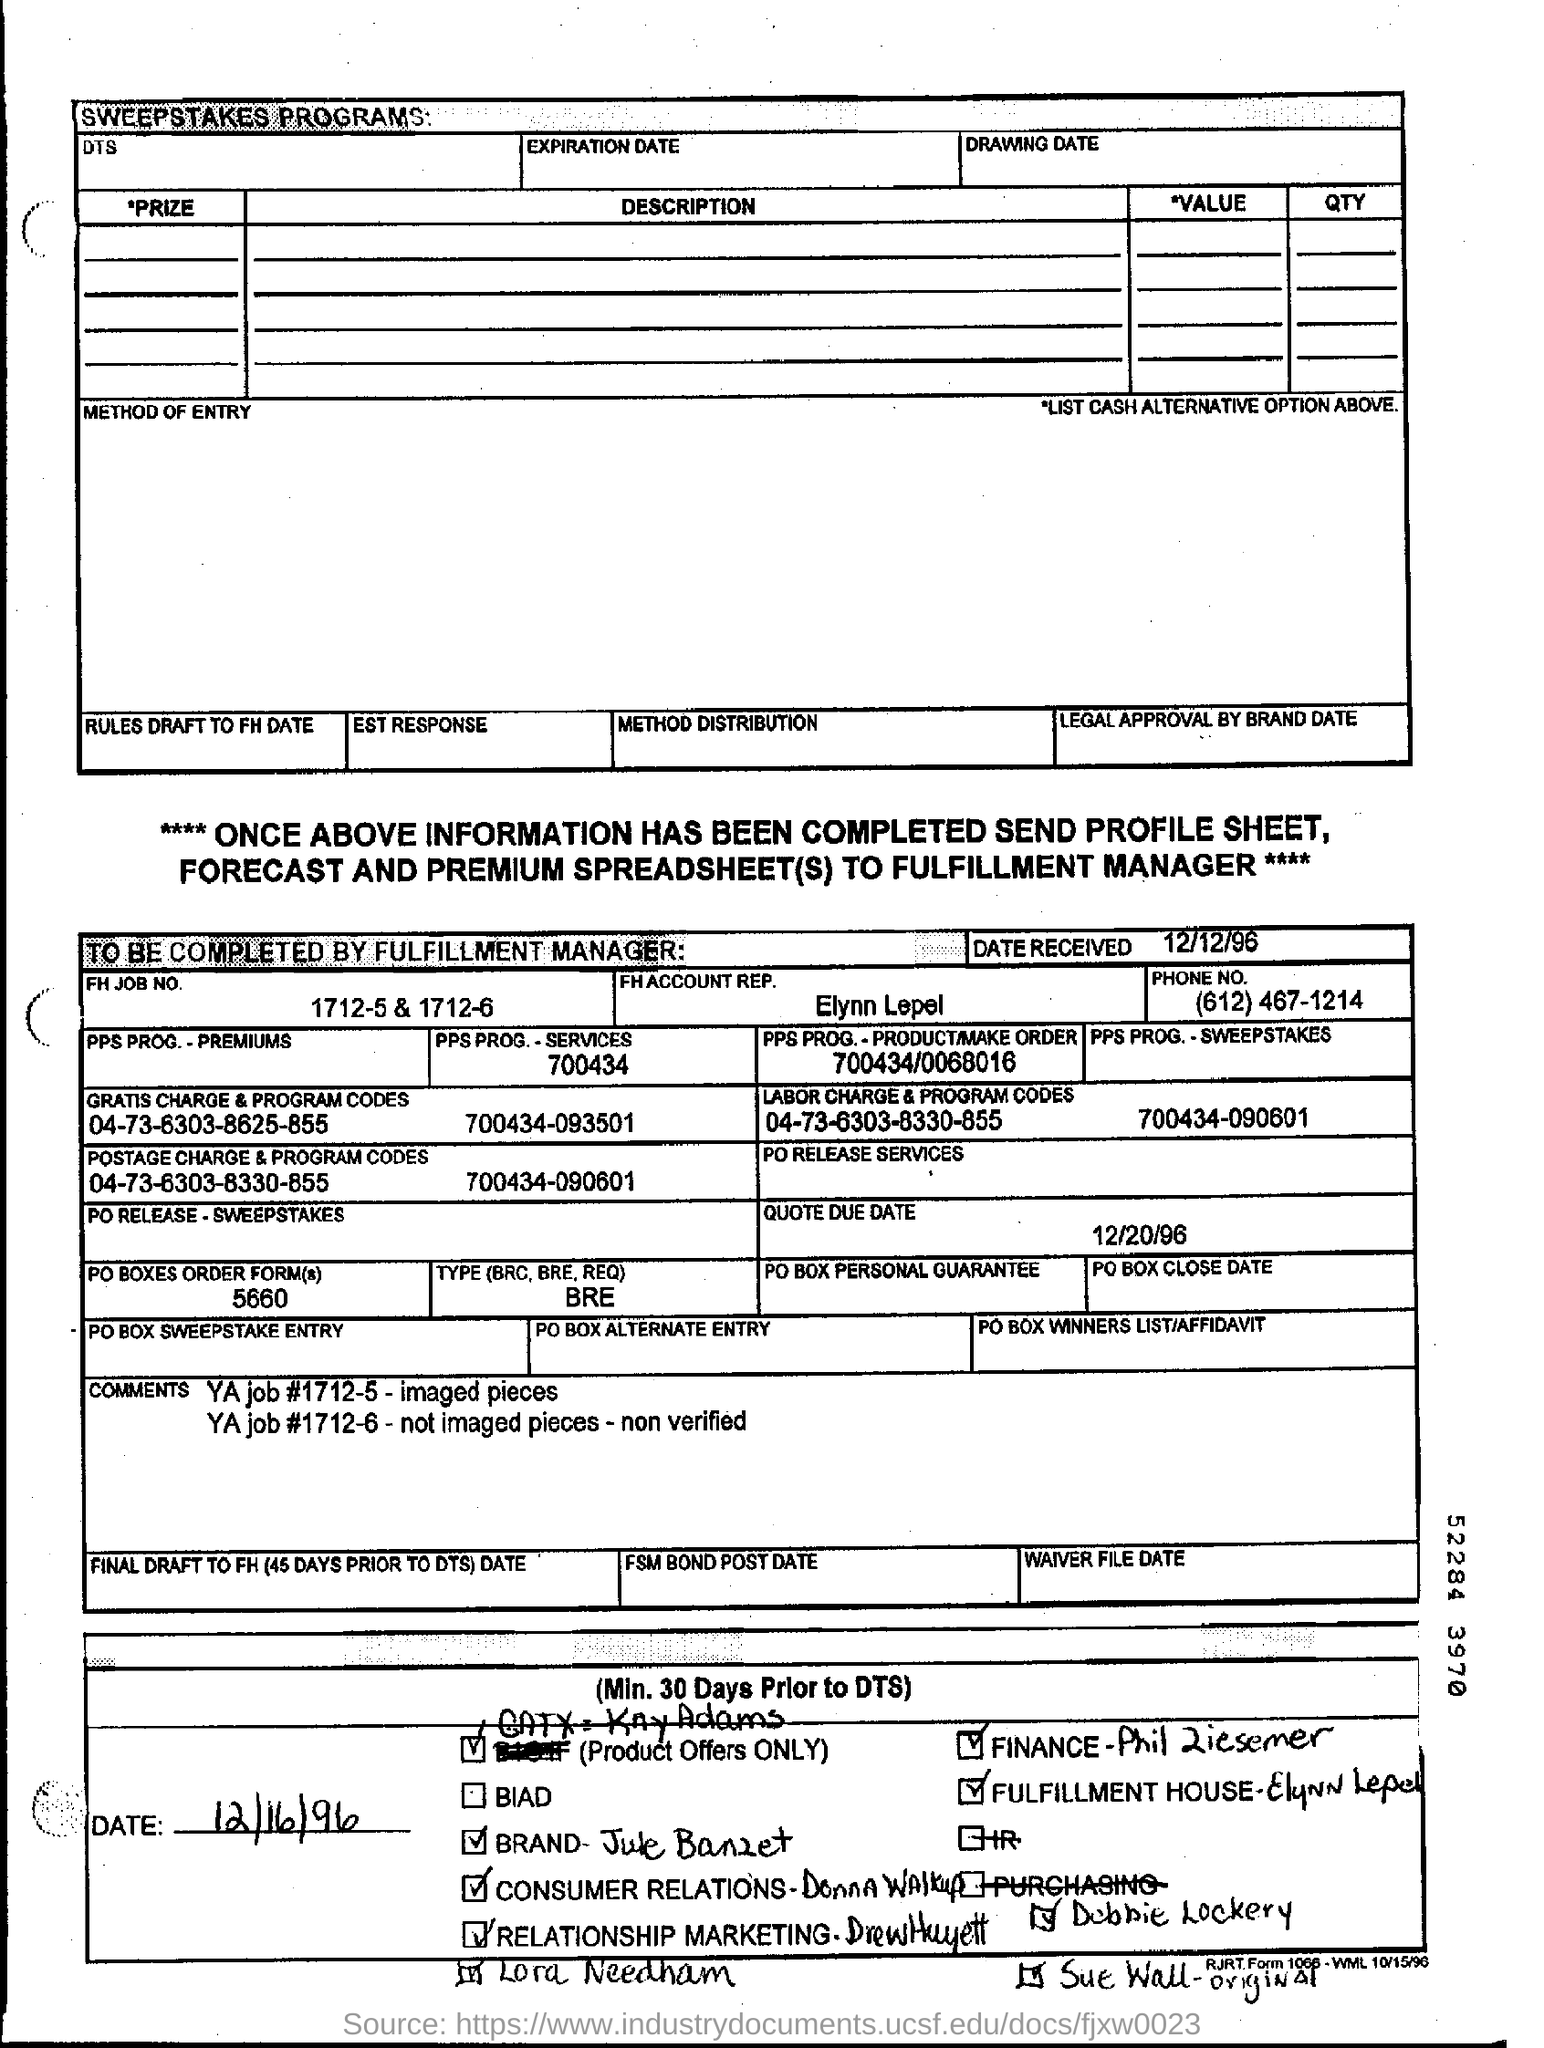List a handful of essential elements in this visual. The FH job number mentioned in this document is 1712-5 and 1712-6. The due date mentioned in the document is December 20, 1996. What is the received date mentioned in the document? December 12, 1996. 